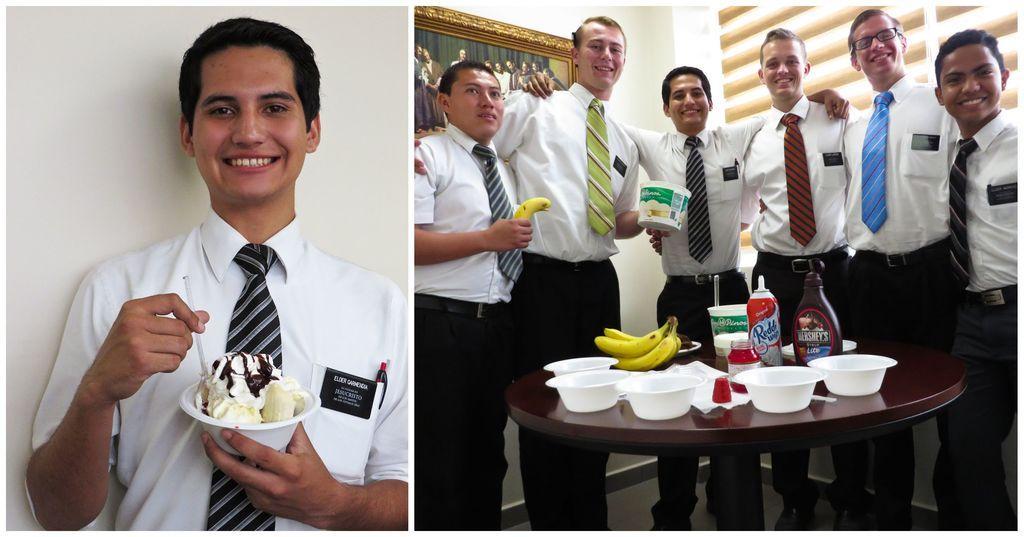Can you describe this image briefly? In this image I can see the collage picture and I can see group of people standing, the person in front is wearing white color shirt and black color tie. In front I can see few bowls, fruits, bottles on the table. Background I can see the frame attached to the wall and the wall is in white color. 